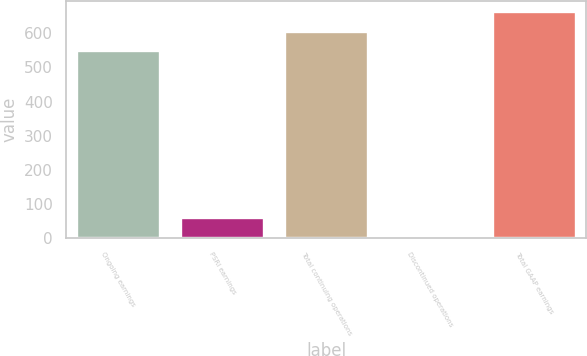<chart> <loc_0><loc_0><loc_500><loc_500><bar_chart><fcel>Ongoing earnings<fcel>PSRI earnings<fcel>Total continuing operations<fcel>Discontinued operations<fcel>Total GAAP earnings<nl><fcel>548.2<fcel>59.97<fcel>605.07<fcel>3.1<fcel>661.94<nl></chart> 